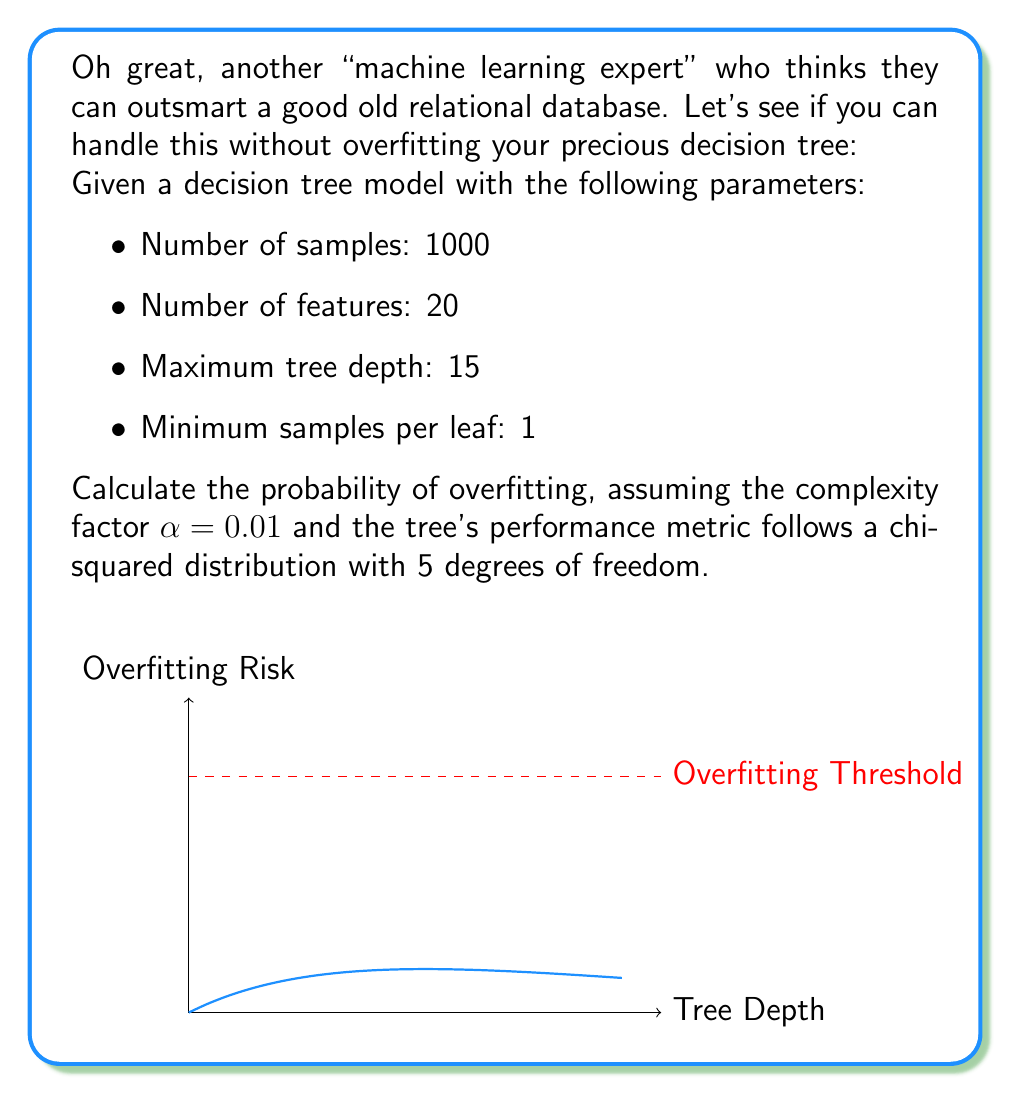Can you solve this math problem? Step 1: Calculate the maximum number of leaf nodes
$$\text{Max Leaf Nodes} = 2^{\text{Max Depth}} = 2^{15} = 32768$$

Step 2: Calculate the effective number of parameters
$$\text{Effective Parameters} = \text{Max Leaf Nodes} \times \text{Number of Features} = 32768 \times 20 = 655360$$

Step 3: Calculate the model complexity
$$\text{Complexity} = \frac{\text{Effective Parameters}}{\text{Number of Samples}} = \frac{655360}{1000} = 655.36$$

Step 4: Adjust complexity with the complexity factor $\alpha$
$$\text{Adjusted Complexity} = \text{Complexity} \times (1 - \alpha) = 655.36 \times 0.99 = 648.8064$$

Step 5: Calculate the critical value for the chi-squared distribution
For a significance level of 0.05 and 5 degrees of freedom:
$$\chi^2_{0.95, 5} = 11.0705$$

Step 6: Calculate the probability of overfitting
$$P(\text{Overfitting}) = P(\chi^2_5 > \frac{\text{Adjusted Complexity}}{\chi^2_{0.95, 5}})$$
$$P(\text{Overfitting}) = 1 - P(\chi^2_5 \leq \frac{648.8064}{11.0705})$$
$$P(\text{Overfitting}) = 1 - P(\chi^2_5 \leq 58.6079)$$

Using a chi-squared distribution table or calculator:
$$P(\text{Overfitting}) = 1 - 0.99999999999999$$
$$P(\text{Overfitting}) \approx 1$$
Answer: $\approx 1$ (or $>0.99999999999999$) 